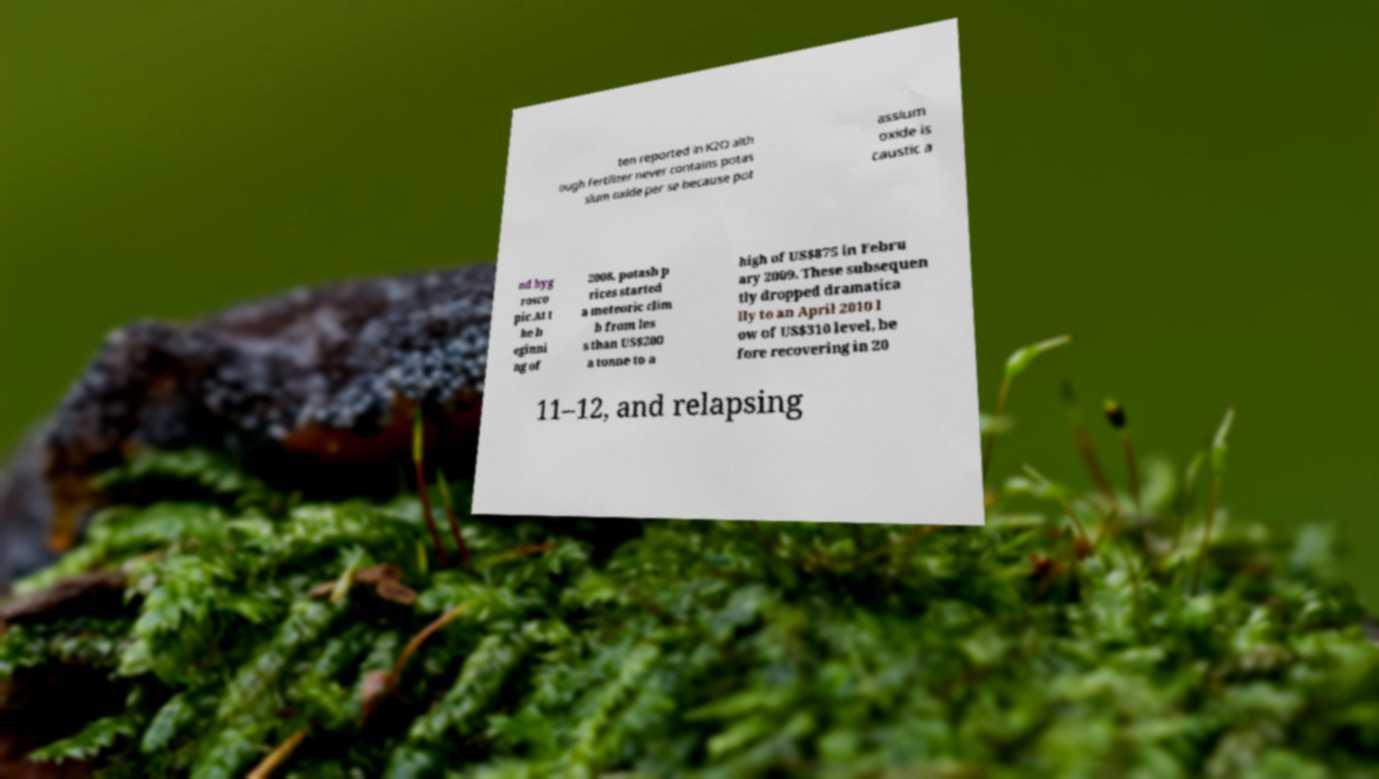There's text embedded in this image that I need extracted. Can you transcribe it verbatim? ten reported in K2O alth ough fertilizer never contains potas sium oxide per se because pot assium oxide is caustic a nd hyg rosco pic.At t he b eginni ng of 2008, potash p rices started a meteoric clim b from les s than US$200 a tonne to a high of US$875 in Febru ary 2009. These subsequen tly dropped dramatica lly to an April 2010 l ow of US$310 level, be fore recovering in 20 11–12, and relapsing 